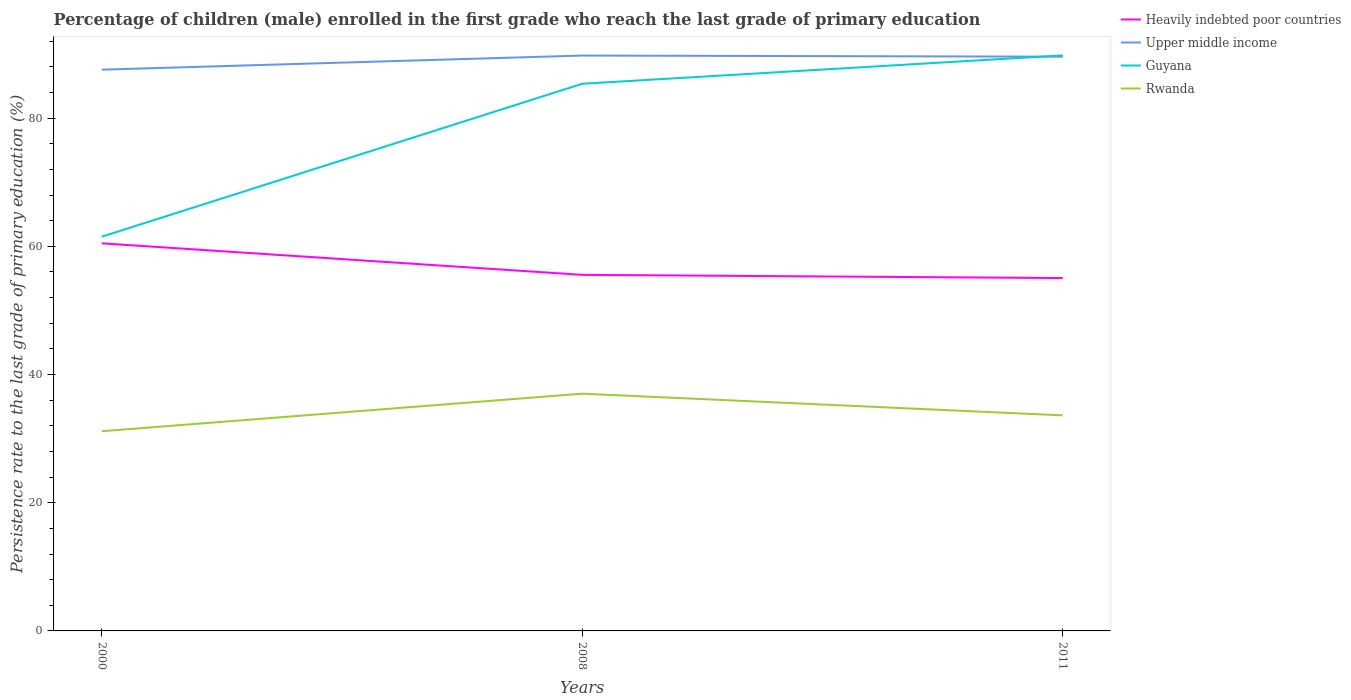How many different coloured lines are there?
Your answer should be very brief. 4. Across all years, what is the maximum persistence rate of children in Guyana?
Your answer should be very brief. 61.5. What is the total persistence rate of children in Upper middle income in the graph?
Provide a succinct answer. 0.18. What is the difference between the highest and the second highest persistence rate of children in Rwanda?
Your answer should be compact. 5.86. How many lines are there?
Your response must be concise. 4. Are the values on the major ticks of Y-axis written in scientific E-notation?
Offer a terse response. No. Does the graph contain any zero values?
Offer a very short reply. No. Where does the legend appear in the graph?
Give a very brief answer. Top right. How many legend labels are there?
Your answer should be very brief. 4. How are the legend labels stacked?
Provide a succinct answer. Vertical. What is the title of the graph?
Make the answer very short. Percentage of children (male) enrolled in the first grade who reach the last grade of primary education. What is the label or title of the X-axis?
Make the answer very short. Years. What is the label or title of the Y-axis?
Provide a succinct answer. Persistence rate to the last grade of primary education (%). What is the Persistence rate to the last grade of primary education (%) in Heavily indebted poor countries in 2000?
Give a very brief answer. 60.47. What is the Persistence rate to the last grade of primary education (%) of Upper middle income in 2000?
Make the answer very short. 87.57. What is the Persistence rate to the last grade of primary education (%) of Guyana in 2000?
Your answer should be very brief. 61.5. What is the Persistence rate to the last grade of primary education (%) in Rwanda in 2000?
Provide a succinct answer. 31.16. What is the Persistence rate to the last grade of primary education (%) in Heavily indebted poor countries in 2008?
Give a very brief answer. 55.55. What is the Persistence rate to the last grade of primary education (%) of Upper middle income in 2008?
Your answer should be very brief. 89.77. What is the Persistence rate to the last grade of primary education (%) in Guyana in 2008?
Provide a succinct answer. 85.37. What is the Persistence rate to the last grade of primary education (%) of Rwanda in 2008?
Your answer should be compact. 37.02. What is the Persistence rate to the last grade of primary education (%) in Heavily indebted poor countries in 2011?
Offer a very short reply. 55.05. What is the Persistence rate to the last grade of primary education (%) in Upper middle income in 2011?
Your answer should be very brief. 89.59. What is the Persistence rate to the last grade of primary education (%) of Guyana in 2011?
Your answer should be very brief. 89.8. What is the Persistence rate to the last grade of primary education (%) in Rwanda in 2011?
Give a very brief answer. 33.63. Across all years, what is the maximum Persistence rate to the last grade of primary education (%) of Heavily indebted poor countries?
Offer a terse response. 60.47. Across all years, what is the maximum Persistence rate to the last grade of primary education (%) in Upper middle income?
Keep it short and to the point. 89.77. Across all years, what is the maximum Persistence rate to the last grade of primary education (%) of Guyana?
Keep it short and to the point. 89.8. Across all years, what is the maximum Persistence rate to the last grade of primary education (%) of Rwanda?
Your answer should be compact. 37.02. Across all years, what is the minimum Persistence rate to the last grade of primary education (%) in Heavily indebted poor countries?
Offer a very short reply. 55.05. Across all years, what is the minimum Persistence rate to the last grade of primary education (%) of Upper middle income?
Offer a terse response. 87.57. Across all years, what is the minimum Persistence rate to the last grade of primary education (%) in Guyana?
Provide a succinct answer. 61.5. Across all years, what is the minimum Persistence rate to the last grade of primary education (%) in Rwanda?
Your response must be concise. 31.16. What is the total Persistence rate to the last grade of primary education (%) in Heavily indebted poor countries in the graph?
Offer a terse response. 171.08. What is the total Persistence rate to the last grade of primary education (%) of Upper middle income in the graph?
Offer a terse response. 266.93. What is the total Persistence rate to the last grade of primary education (%) of Guyana in the graph?
Your response must be concise. 236.67. What is the total Persistence rate to the last grade of primary education (%) of Rwanda in the graph?
Your answer should be very brief. 101.8. What is the difference between the Persistence rate to the last grade of primary education (%) in Heavily indebted poor countries in 2000 and that in 2008?
Keep it short and to the point. 4.92. What is the difference between the Persistence rate to the last grade of primary education (%) of Upper middle income in 2000 and that in 2008?
Keep it short and to the point. -2.2. What is the difference between the Persistence rate to the last grade of primary education (%) in Guyana in 2000 and that in 2008?
Provide a short and direct response. -23.87. What is the difference between the Persistence rate to the last grade of primary education (%) in Rwanda in 2000 and that in 2008?
Make the answer very short. -5.86. What is the difference between the Persistence rate to the last grade of primary education (%) of Heavily indebted poor countries in 2000 and that in 2011?
Your answer should be compact. 5.42. What is the difference between the Persistence rate to the last grade of primary education (%) of Upper middle income in 2000 and that in 2011?
Provide a short and direct response. -2.03. What is the difference between the Persistence rate to the last grade of primary education (%) in Guyana in 2000 and that in 2011?
Your answer should be compact. -28.3. What is the difference between the Persistence rate to the last grade of primary education (%) in Rwanda in 2000 and that in 2011?
Keep it short and to the point. -2.47. What is the difference between the Persistence rate to the last grade of primary education (%) of Heavily indebted poor countries in 2008 and that in 2011?
Make the answer very short. 0.5. What is the difference between the Persistence rate to the last grade of primary education (%) in Upper middle income in 2008 and that in 2011?
Offer a very short reply. 0.18. What is the difference between the Persistence rate to the last grade of primary education (%) of Guyana in 2008 and that in 2011?
Your response must be concise. -4.43. What is the difference between the Persistence rate to the last grade of primary education (%) of Rwanda in 2008 and that in 2011?
Offer a very short reply. 3.38. What is the difference between the Persistence rate to the last grade of primary education (%) in Heavily indebted poor countries in 2000 and the Persistence rate to the last grade of primary education (%) in Upper middle income in 2008?
Your response must be concise. -29.3. What is the difference between the Persistence rate to the last grade of primary education (%) of Heavily indebted poor countries in 2000 and the Persistence rate to the last grade of primary education (%) of Guyana in 2008?
Provide a short and direct response. -24.9. What is the difference between the Persistence rate to the last grade of primary education (%) of Heavily indebted poor countries in 2000 and the Persistence rate to the last grade of primary education (%) of Rwanda in 2008?
Your answer should be compact. 23.46. What is the difference between the Persistence rate to the last grade of primary education (%) in Upper middle income in 2000 and the Persistence rate to the last grade of primary education (%) in Guyana in 2008?
Provide a succinct answer. 2.2. What is the difference between the Persistence rate to the last grade of primary education (%) of Upper middle income in 2000 and the Persistence rate to the last grade of primary education (%) of Rwanda in 2008?
Offer a terse response. 50.55. What is the difference between the Persistence rate to the last grade of primary education (%) of Guyana in 2000 and the Persistence rate to the last grade of primary education (%) of Rwanda in 2008?
Your answer should be compact. 24.49. What is the difference between the Persistence rate to the last grade of primary education (%) of Heavily indebted poor countries in 2000 and the Persistence rate to the last grade of primary education (%) of Upper middle income in 2011?
Ensure brevity in your answer.  -29.12. What is the difference between the Persistence rate to the last grade of primary education (%) in Heavily indebted poor countries in 2000 and the Persistence rate to the last grade of primary education (%) in Guyana in 2011?
Make the answer very short. -29.33. What is the difference between the Persistence rate to the last grade of primary education (%) of Heavily indebted poor countries in 2000 and the Persistence rate to the last grade of primary education (%) of Rwanda in 2011?
Provide a succinct answer. 26.84. What is the difference between the Persistence rate to the last grade of primary education (%) in Upper middle income in 2000 and the Persistence rate to the last grade of primary education (%) in Guyana in 2011?
Offer a terse response. -2.23. What is the difference between the Persistence rate to the last grade of primary education (%) in Upper middle income in 2000 and the Persistence rate to the last grade of primary education (%) in Rwanda in 2011?
Give a very brief answer. 53.94. What is the difference between the Persistence rate to the last grade of primary education (%) of Guyana in 2000 and the Persistence rate to the last grade of primary education (%) of Rwanda in 2011?
Your response must be concise. 27.87. What is the difference between the Persistence rate to the last grade of primary education (%) in Heavily indebted poor countries in 2008 and the Persistence rate to the last grade of primary education (%) in Upper middle income in 2011?
Your answer should be very brief. -34.04. What is the difference between the Persistence rate to the last grade of primary education (%) of Heavily indebted poor countries in 2008 and the Persistence rate to the last grade of primary education (%) of Guyana in 2011?
Provide a succinct answer. -34.24. What is the difference between the Persistence rate to the last grade of primary education (%) in Heavily indebted poor countries in 2008 and the Persistence rate to the last grade of primary education (%) in Rwanda in 2011?
Make the answer very short. 21.92. What is the difference between the Persistence rate to the last grade of primary education (%) in Upper middle income in 2008 and the Persistence rate to the last grade of primary education (%) in Guyana in 2011?
Your answer should be compact. -0.03. What is the difference between the Persistence rate to the last grade of primary education (%) in Upper middle income in 2008 and the Persistence rate to the last grade of primary education (%) in Rwanda in 2011?
Provide a short and direct response. 56.14. What is the difference between the Persistence rate to the last grade of primary education (%) of Guyana in 2008 and the Persistence rate to the last grade of primary education (%) of Rwanda in 2011?
Make the answer very short. 51.74. What is the average Persistence rate to the last grade of primary education (%) of Heavily indebted poor countries per year?
Provide a short and direct response. 57.03. What is the average Persistence rate to the last grade of primary education (%) of Upper middle income per year?
Offer a terse response. 88.98. What is the average Persistence rate to the last grade of primary education (%) of Guyana per year?
Give a very brief answer. 78.89. What is the average Persistence rate to the last grade of primary education (%) of Rwanda per year?
Offer a very short reply. 33.93. In the year 2000, what is the difference between the Persistence rate to the last grade of primary education (%) of Heavily indebted poor countries and Persistence rate to the last grade of primary education (%) of Upper middle income?
Your response must be concise. -27.09. In the year 2000, what is the difference between the Persistence rate to the last grade of primary education (%) of Heavily indebted poor countries and Persistence rate to the last grade of primary education (%) of Guyana?
Offer a terse response. -1.03. In the year 2000, what is the difference between the Persistence rate to the last grade of primary education (%) in Heavily indebted poor countries and Persistence rate to the last grade of primary education (%) in Rwanda?
Keep it short and to the point. 29.32. In the year 2000, what is the difference between the Persistence rate to the last grade of primary education (%) of Upper middle income and Persistence rate to the last grade of primary education (%) of Guyana?
Ensure brevity in your answer.  26.06. In the year 2000, what is the difference between the Persistence rate to the last grade of primary education (%) of Upper middle income and Persistence rate to the last grade of primary education (%) of Rwanda?
Your answer should be very brief. 56.41. In the year 2000, what is the difference between the Persistence rate to the last grade of primary education (%) in Guyana and Persistence rate to the last grade of primary education (%) in Rwanda?
Your response must be concise. 30.35. In the year 2008, what is the difference between the Persistence rate to the last grade of primary education (%) of Heavily indebted poor countries and Persistence rate to the last grade of primary education (%) of Upper middle income?
Your answer should be compact. -34.22. In the year 2008, what is the difference between the Persistence rate to the last grade of primary education (%) of Heavily indebted poor countries and Persistence rate to the last grade of primary education (%) of Guyana?
Offer a very short reply. -29.81. In the year 2008, what is the difference between the Persistence rate to the last grade of primary education (%) in Heavily indebted poor countries and Persistence rate to the last grade of primary education (%) in Rwanda?
Your answer should be very brief. 18.54. In the year 2008, what is the difference between the Persistence rate to the last grade of primary education (%) of Upper middle income and Persistence rate to the last grade of primary education (%) of Guyana?
Keep it short and to the point. 4.4. In the year 2008, what is the difference between the Persistence rate to the last grade of primary education (%) of Upper middle income and Persistence rate to the last grade of primary education (%) of Rwanda?
Offer a terse response. 52.75. In the year 2008, what is the difference between the Persistence rate to the last grade of primary education (%) in Guyana and Persistence rate to the last grade of primary education (%) in Rwanda?
Offer a terse response. 48.35. In the year 2011, what is the difference between the Persistence rate to the last grade of primary education (%) of Heavily indebted poor countries and Persistence rate to the last grade of primary education (%) of Upper middle income?
Ensure brevity in your answer.  -34.54. In the year 2011, what is the difference between the Persistence rate to the last grade of primary education (%) of Heavily indebted poor countries and Persistence rate to the last grade of primary education (%) of Guyana?
Ensure brevity in your answer.  -34.74. In the year 2011, what is the difference between the Persistence rate to the last grade of primary education (%) of Heavily indebted poor countries and Persistence rate to the last grade of primary education (%) of Rwanda?
Your response must be concise. 21.42. In the year 2011, what is the difference between the Persistence rate to the last grade of primary education (%) of Upper middle income and Persistence rate to the last grade of primary education (%) of Guyana?
Your answer should be very brief. -0.21. In the year 2011, what is the difference between the Persistence rate to the last grade of primary education (%) in Upper middle income and Persistence rate to the last grade of primary education (%) in Rwanda?
Offer a very short reply. 55.96. In the year 2011, what is the difference between the Persistence rate to the last grade of primary education (%) in Guyana and Persistence rate to the last grade of primary education (%) in Rwanda?
Offer a terse response. 56.17. What is the ratio of the Persistence rate to the last grade of primary education (%) of Heavily indebted poor countries in 2000 to that in 2008?
Keep it short and to the point. 1.09. What is the ratio of the Persistence rate to the last grade of primary education (%) of Upper middle income in 2000 to that in 2008?
Provide a short and direct response. 0.98. What is the ratio of the Persistence rate to the last grade of primary education (%) of Guyana in 2000 to that in 2008?
Give a very brief answer. 0.72. What is the ratio of the Persistence rate to the last grade of primary education (%) in Rwanda in 2000 to that in 2008?
Ensure brevity in your answer.  0.84. What is the ratio of the Persistence rate to the last grade of primary education (%) of Heavily indebted poor countries in 2000 to that in 2011?
Your answer should be compact. 1.1. What is the ratio of the Persistence rate to the last grade of primary education (%) in Upper middle income in 2000 to that in 2011?
Offer a terse response. 0.98. What is the ratio of the Persistence rate to the last grade of primary education (%) of Guyana in 2000 to that in 2011?
Offer a very short reply. 0.68. What is the ratio of the Persistence rate to the last grade of primary education (%) of Rwanda in 2000 to that in 2011?
Provide a short and direct response. 0.93. What is the ratio of the Persistence rate to the last grade of primary education (%) of Heavily indebted poor countries in 2008 to that in 2011?
Your response must be concise. 1.01. What is the ratio of the Persistence rate to the last grade of primary education (%) in Upper middle income in 2008 to that in 2011?
Make the answer very short. 1. What is the ratio of the Persistence rate to the last grade of primary education (%) in Guyana in 2008 to that in 2011?
Give a very brief answer. 0.95. What is the ratio of the Persistence rate to the last grade of primary education (%) of Rwanda in 2008 to that in 2011?
Give a very brief answer. 1.1. What is the difference between the highest and the second highest Persistence rate to the last grade of primary education (%) of Heavily indebted poor countries?
Offer a very short reply. 4.92. What is the difference between the highest and the second highest Persistence rate to the last grade of primary education (%) in Upper middle income?
Your answer should be very brief. 0.18. What is the difference between the highest and the second highest Persistence rate to the last grade of primary education (%) in Guyana?
Provide a succinct answer. 4.43. What is the difference between the highest and the second highest Persistence rate to the last grade of primary education (%) of Rwanda?
Your answer should be very brief. 3.38. What is the difference between the highest and the lowest Persistence rate to the last grade of primary education (%) of Heavily indebted poor countries?
Offer a very short reply. 5.42. What is the difference between the highest and the lowest Persistence rate to the last grade of primary education (%) of Upper middle income?
Offer a terse response. 2.2. What is the difference between the highest and the lowest Persistence rate to the last grade of primary education (%) of Guyana?
Provide a short and direct response. 28.3. What is the difference between the highest and the lowest Persistence rate to the last grade of primary education (%) of Rwanda?
Keep it short and to the point. 5.86. 